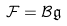Convert formula to latex. <formula><loc_0><loc_0><loc_500><loc_500>\mathcal { F } = \mathcal { B } \mathfrak { g }</formula> 